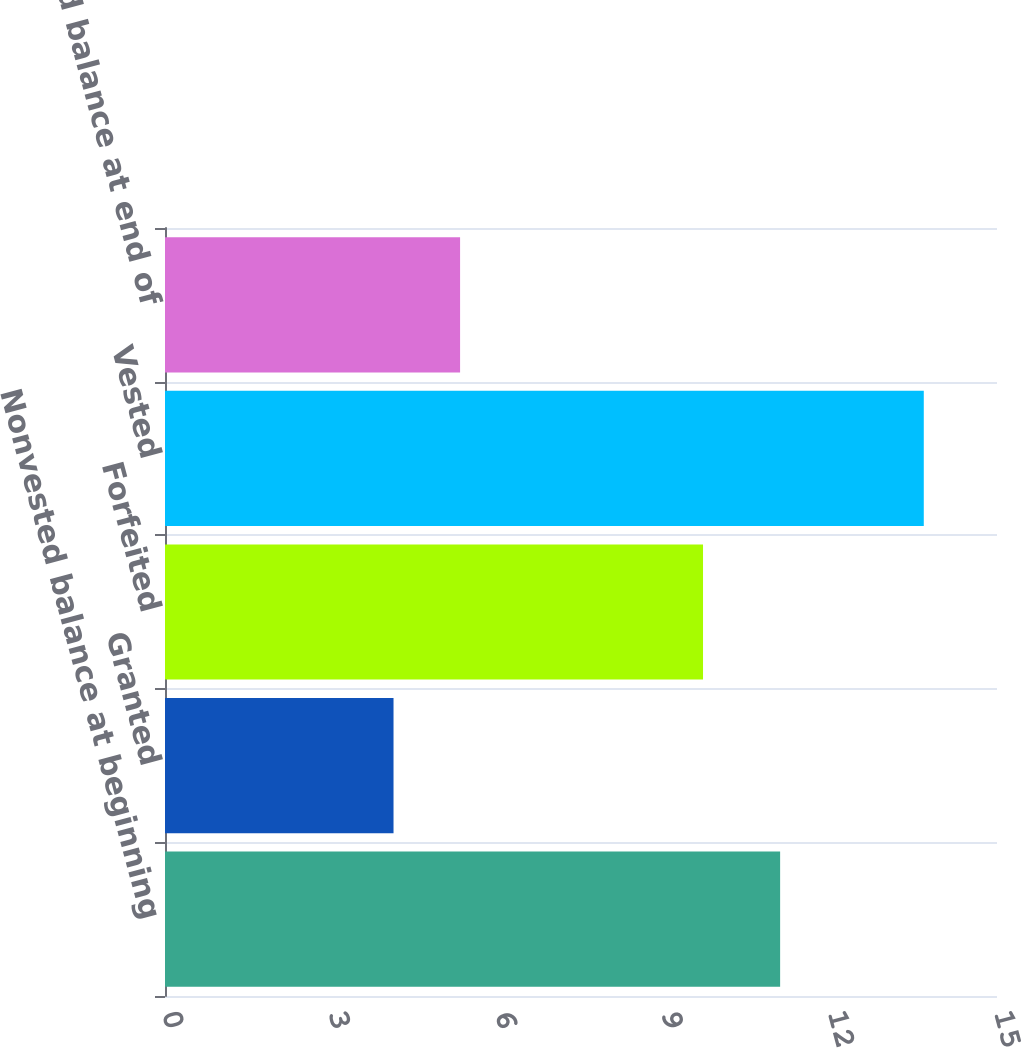Convert chart to OTSL. <chart><loc_0><loc_0><loc_500><loc_500><bar_chart><fcel>Nonvested balance at beginning<fcel>Granted<fcel>Forfeited<fcel>Vested<fcel>Nonvested balance at end of<nl><fcel>11.09<fcel>4.12<fcel>9.7<fcel>13.68<fcel>5.32<nl></chart> 